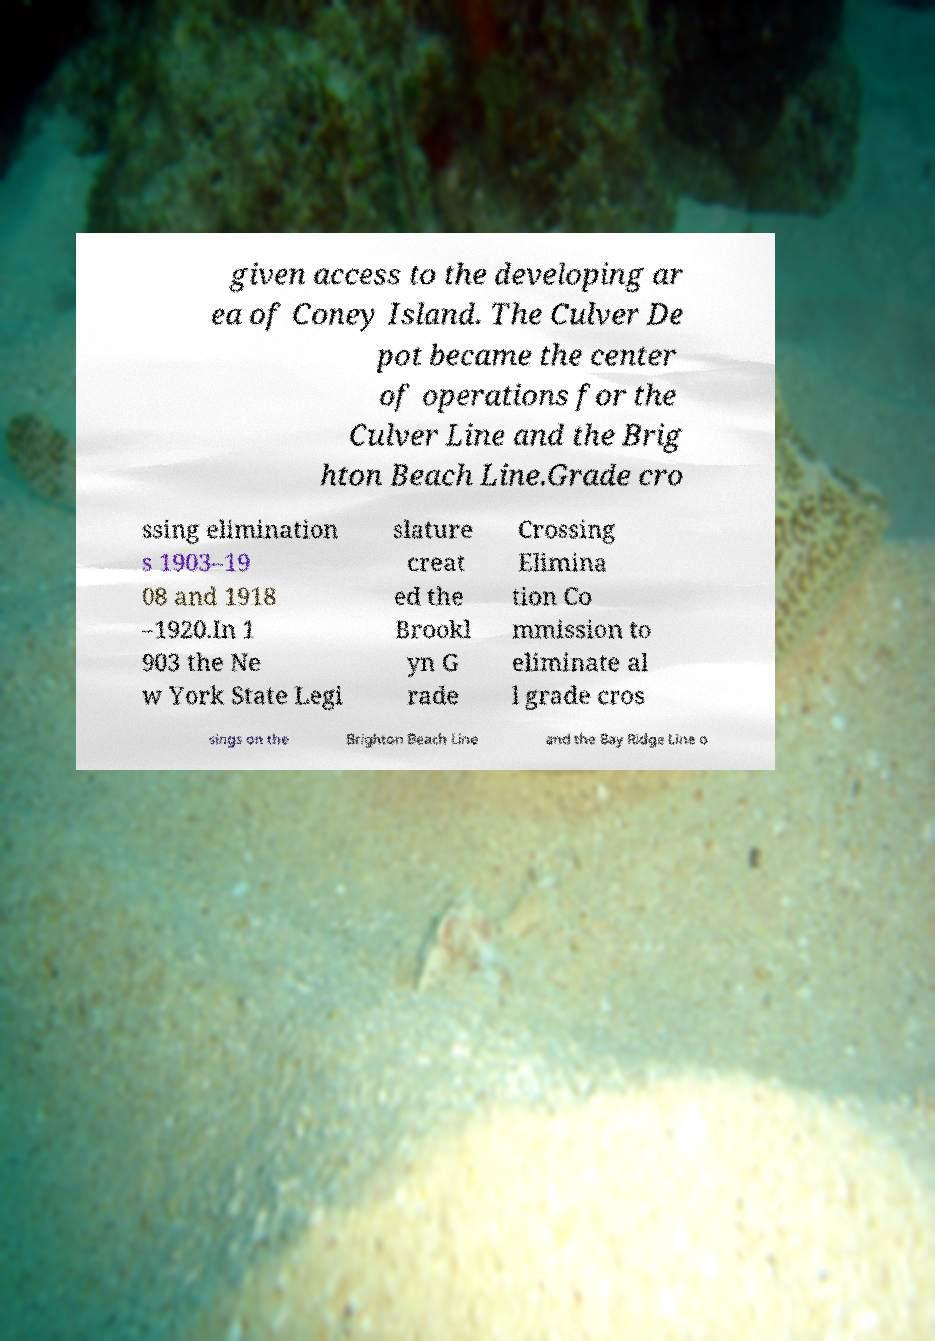Could you extract and type out the text from this image? given access to the developing ar ea of Coney Island. The Culver De pot became the center of operations for the Culver Line and the Brig hton Beach Line.Grade cro ssing elimination s 1903–19 08 and 1918 –1920.In 1 903 the Ne w York State Legi slature creat ed the Brookl yn G rade Crossing Elimina tion Co mmission to eliminate al l grade cros sings on the Brighton Beach Line and the Bay Ridge Line o 